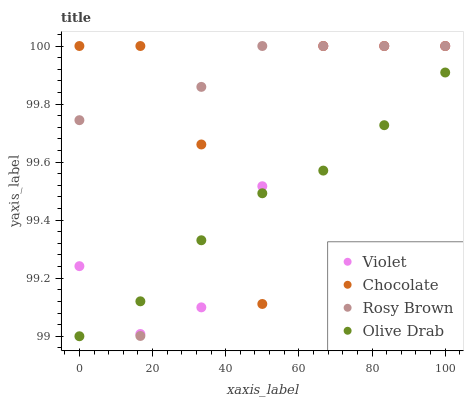Does Olive Drab have the minimum area under the curve?
Answer yes or no. Yes. Does Chocolate have the maximum area under the curve?
Answer yes or no. Yes. Does Chocolate have the minimum area under the curve?
Answer yes or no. No. Does Olive Drab have the maximum area under the curve?
Answer yes or no. No. Is Olive Drab the smoothest?
Answer yes or no. Yes. Is Chocolate the roughest?
Answer yes or no. Yes. Is Chocolate the smoothest?
Answer yes or no. No. Is Olive Drab the roughest?
Answer yes or no. No. Does Olive Drab have the lowest value?
Answer yes or no. Yes. Does Chocolate have the lowest value?
Answer yes or no. No. Does Violet have the highest value?
Answer yes or no. Yes. Does Olive Drab have the highest value?
Answer yes or no. No. Does Rosy Brown intersect Violet?
Answer yes or no. Yes. Is Rosy Brown less than Violet?
Answer yes or no. No. Is Rosy Brown greater than Violet?
Answer yes or no. No. 